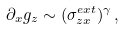<formula> <loc_0><loc_0><loc_500><loc_500>\partial _ { x } g _ { z } \sim ( \sigma _ { z x } ^ { e x t } ) ^ { \gamma } \, ,</formula> 